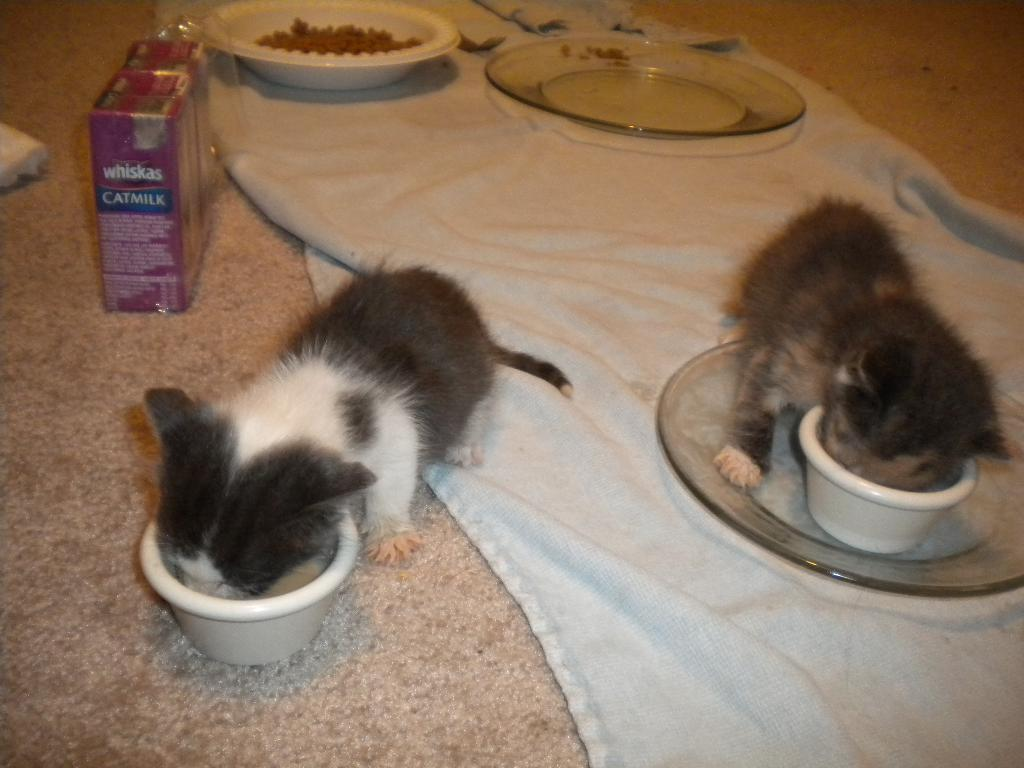What is on the floor in the image? There is a carpet on the floor in the image. What objects are present on the carpet? There are plates and packets visible on the carpet. How many carts are in the image? Two carts are present in the image. What are the carts doing in the image? The carts are eating. What type of suit is the queen wearing in the image? There is no queen or suit present in the image. What is the value of the item on the carts' plates in the image? The value of the items on the carts' plates cannot be determined from the image. 